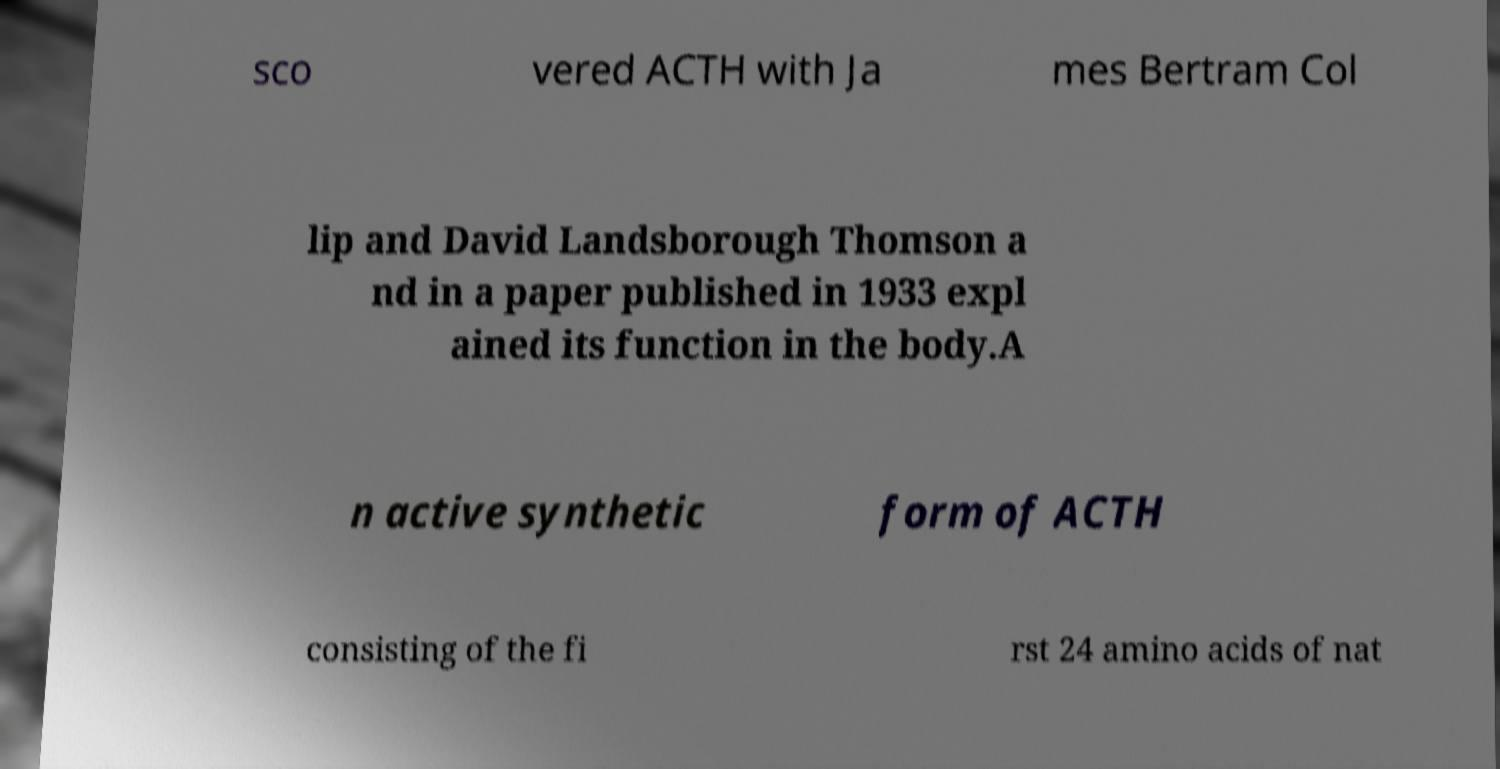There's text embedded in this image that I need extracted. Can you transcribe it verbatim? sco vered ACTH with Ja mes Bertram Col lip and David Landsborough Thomson a nd in a paper published in 1933 expl ained its function in the body.A n active synthetic form of ACTH consisting of the fi rst 24 amino acids of nat 